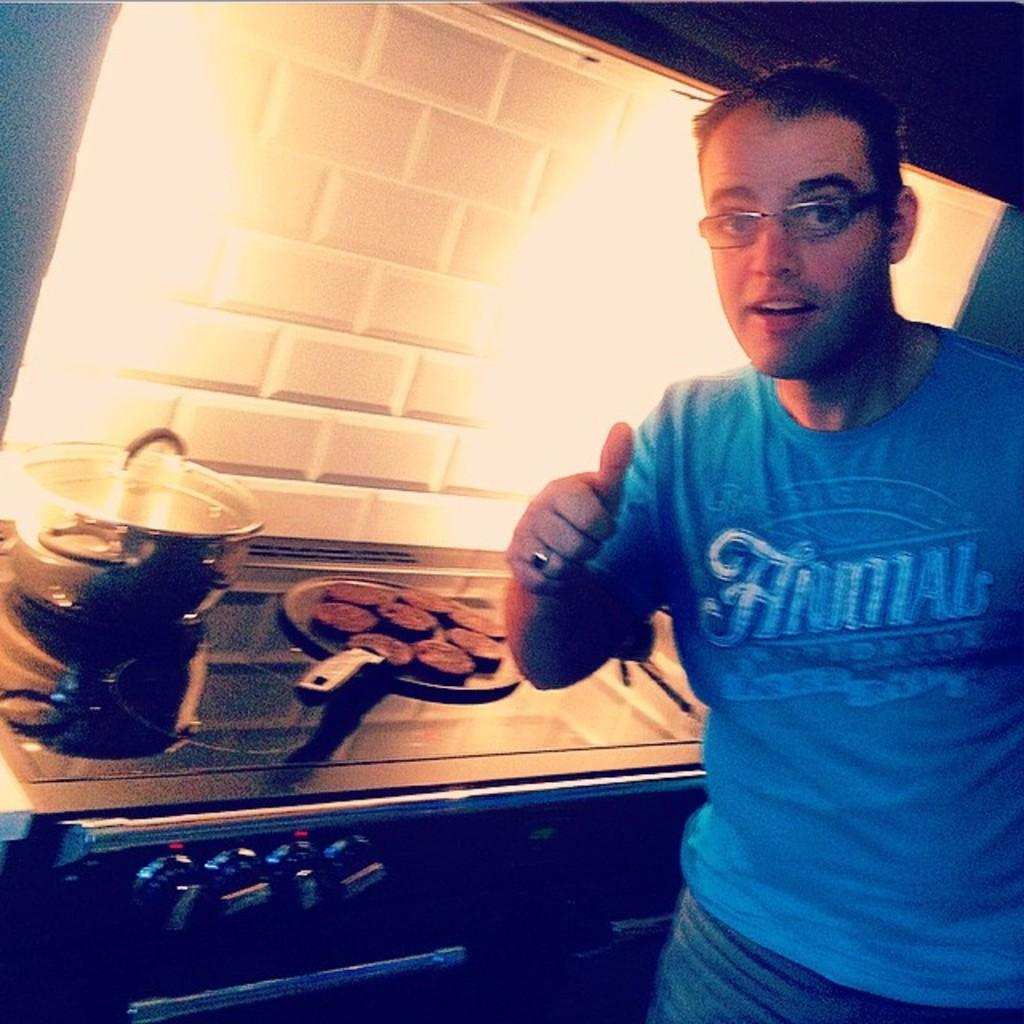<image>
Relay a brief, clear account of the picture shown. A man gives a thumbs up while wearing a blue shirt that says ANIMAL. 